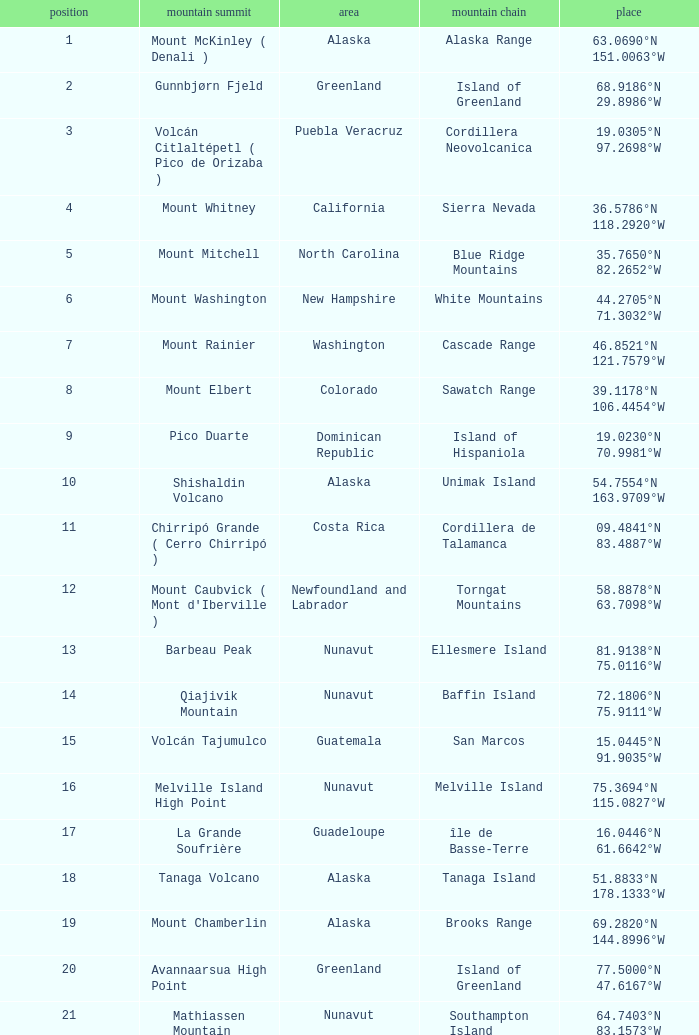Name the Mountain Peak which has a Rank of 62? Cerro Nube ( Quie Yelaag ). 